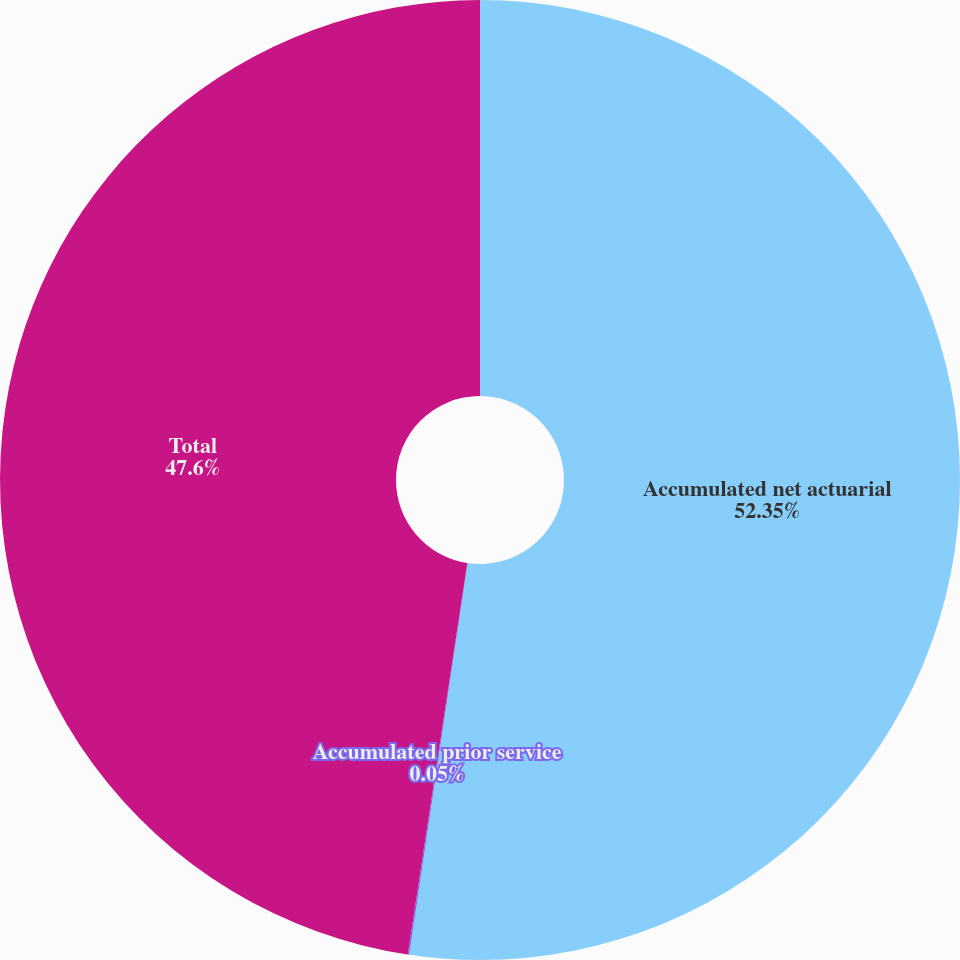<chart> <loc_0><loc_0><loc_500><loc_500><pie_chart><fcel>Accumulated net actuarial<fcel>Accumulated prior service<fcel>Total<nl><fcel>52.36%<fcel>0.05%<fcel>47.6%<nl></chart> 